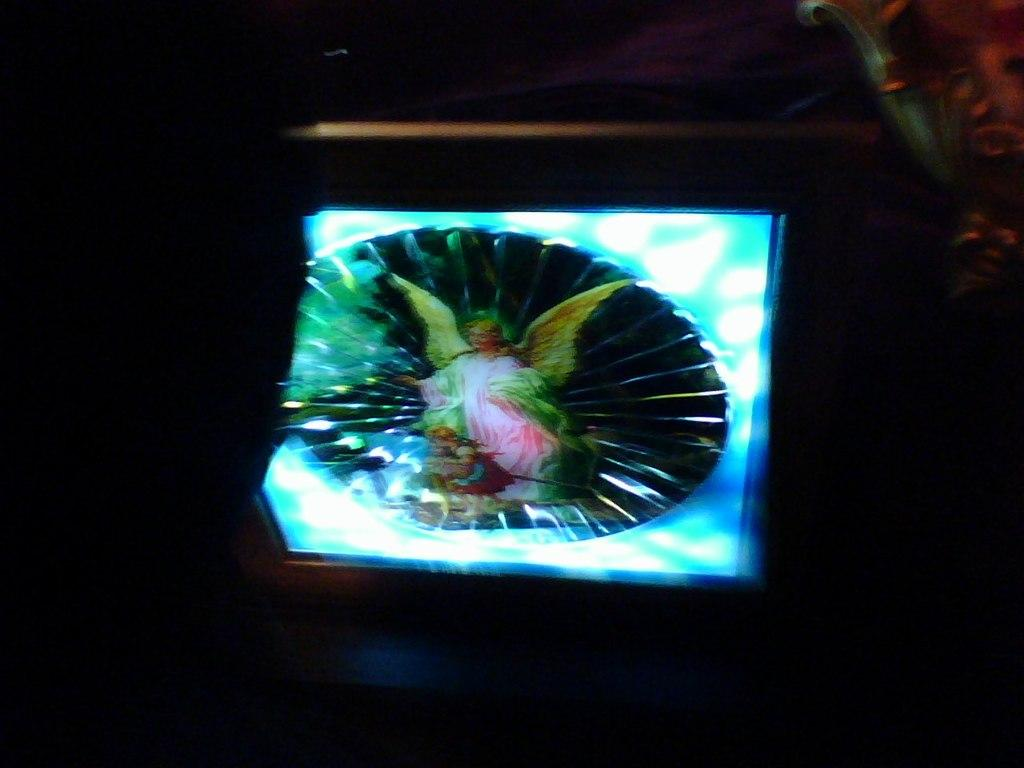What is the overall lighting condition in the image? The image is dark. What can be seen on the screen in the image? A person with wings is displayed on the screen. What type of beam is being used to support the person with wings in the image? There is no beam present in the image; the person with wings is displayed on a screen. How does the person with wings in the image express pain? The image does not show any expression of pain, as it only displays a person with wings on a screen. 